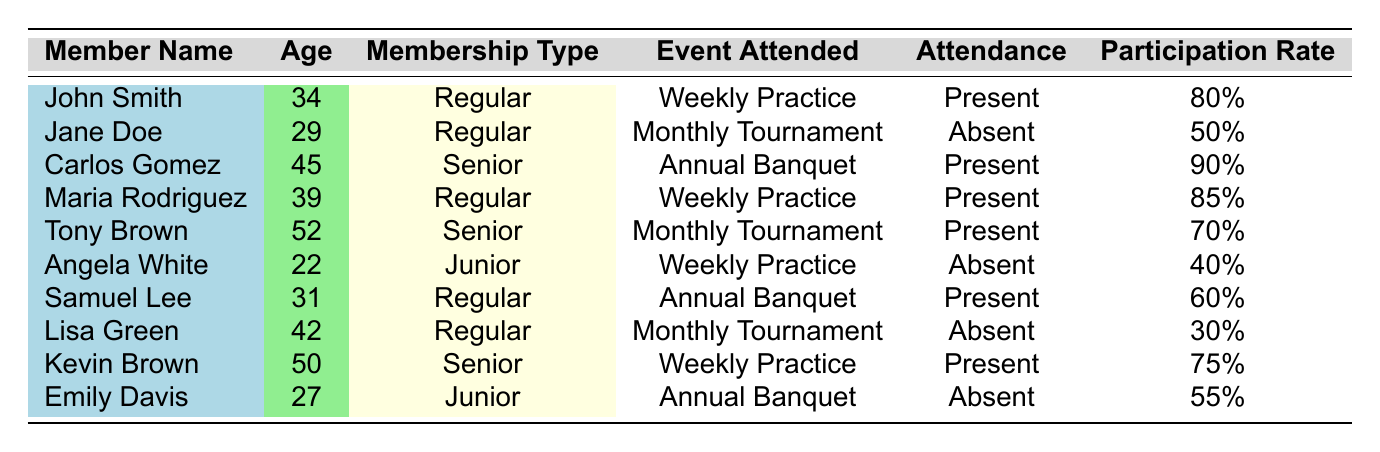What is the attendance status of Carlos Gomez? According to the table, Carlos Gomez is listed under attendance, and his status is marked as "Present."
Answer: Present How many members have a participation rate of 80% or higher? By scanning the table, we see that John Smith (80%), Carlos Gomez (90%), Maria Rodriguez (85%), and Samuel Lee (60%) are listed. However, only John Smith, Carlos Gomez, and Maria Rodriguez meet the criteria of being 80% or higher. Therefore, there are three members.
Answer: 3 What is the average age of members who attended the Monthly Tournament? The members who attended the Monthly Tournament are Jane Doe (29), Tony Brown (52), and Lisa Green (42). Adding these ages gives 29 + 52 + 42 = 123. There are three members, so the average age is 123/3 = 41.
Answer: 41 Is Angela White older than Kevin Brown? Angela White is 22 years old, while Kevin Brown is 50 years old. Since 22 is not greater than 50, the statement is false.
Answer: No Which event had the highest participation rate among the present attendees? The present attendees from the table are Carlos Gomez (90%), John Smith (80%), Maria Rodriguez (85%), Tony Brown (70%), and Kevin Brown (75%). Among these, Carlos Gomez has the highest participation rate at 90%.
Answer: 90% 